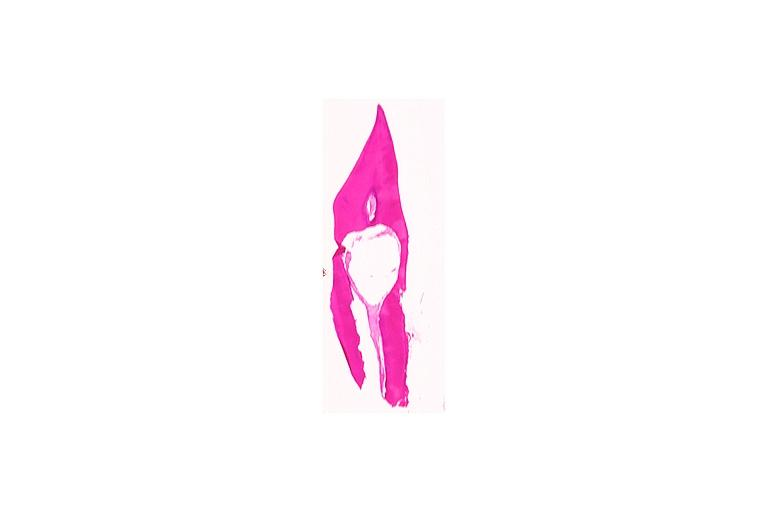s oral present?
Answer the question using a single word or phrase. Yes 